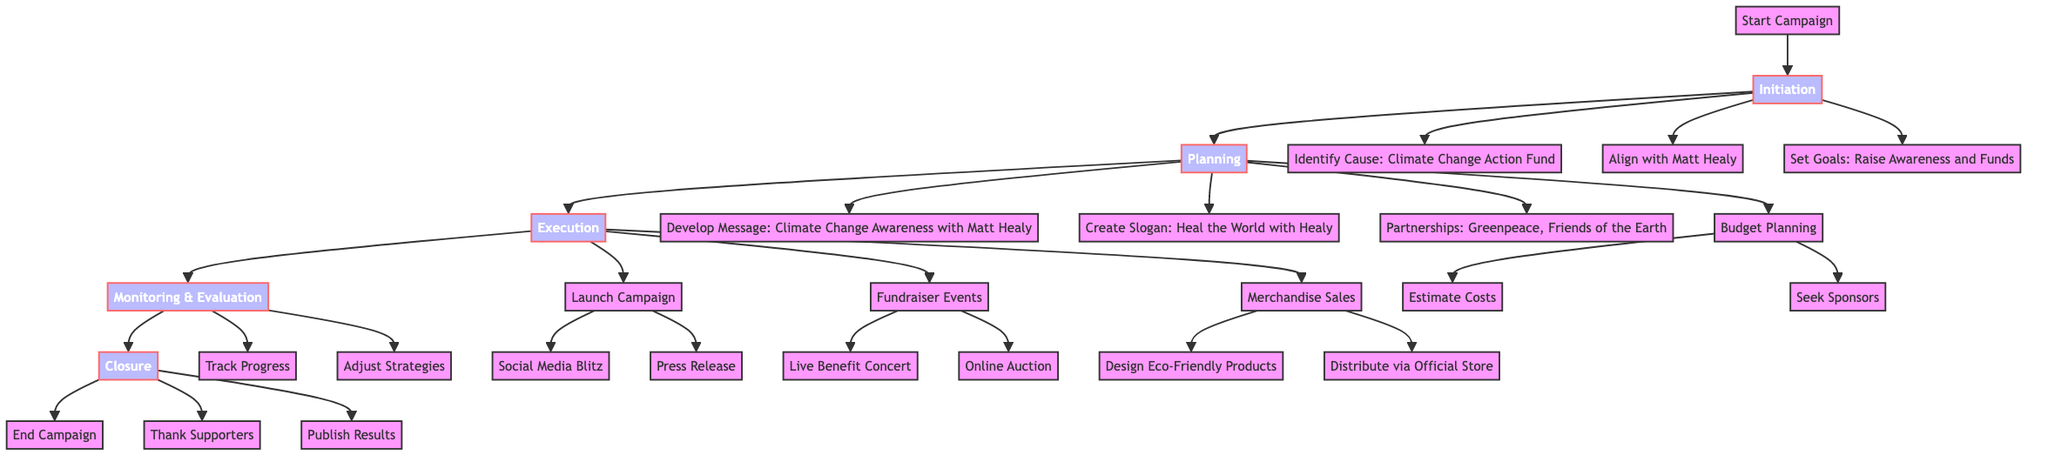What is the cause identified in the campaign? The diagram specifies that the cause identified in the Initiation phase is the "Climate Change Action Fund." This can be found directly under the node labeled "Identify Cause."
Answer: Climate Change Action Fund How many partnerships are listed in the planning phase? In the planning phase, two partnerships are clearly listed: "Greenpeace" and "Friends of the Earth." Therefore, counting these gives a total of two.
Answer: 2 What is the slogan created for the campaign? The slogan developed in the planning phase is "Heal the World with Healy," which can be found under the node "Create Slogan."
Answer: Heal the World with Healy Which social media platforms are included in the social media blitz? The social media blitz includes three platforms: Instagram, Twitter, and TikTok. This information is detailed under the "Social Media Blitz" node in the execution phase.
Answer: Instagram, Twitter, TikTok What step follows the "Launch Campaign" node? The node that directly follows "Launch Campaign" in the execution phase is "Fundraiser Events." This indicates the flow from launching the campaign to organizing events under the execution section.
Answer: Fundraiser Events What kind of products are designed for merchandise sales? The diagram states that "Eco-Friendly Products" are to be designed, with specific examples of T-Shirts and Reusable Bags provided. This information is under the "Design EcoFriendly Products" node.
Answer: Eco-Friendly Products How is performance tracked in the monitoring and evaluation phase? The diagram lists "Social Media Engagement" and "Funds Raised" as the metrics used to track progress in the monitoring and evaluation phase. Therefore, these two components form the basis of tracking performance.
Answer: Social Media Engagement, Funds Raised What happens during the closure phase after thanking supporters? According to the closure phase in the diagram, after "Thank Supporters," the next step is to "Publish Results." Thus, this indicates the sequential actions taken during closure.
Answer: Publish Results Which type of event is featured in the fundraiser events? The fundraising events include a "Live Benefit Concert Featuring The 1975," which highlights the significant event planned to support the campaign. This is specified under the node for "Fundraiser Events."
Answer: Live Benefit Concert Featuring The 1975 